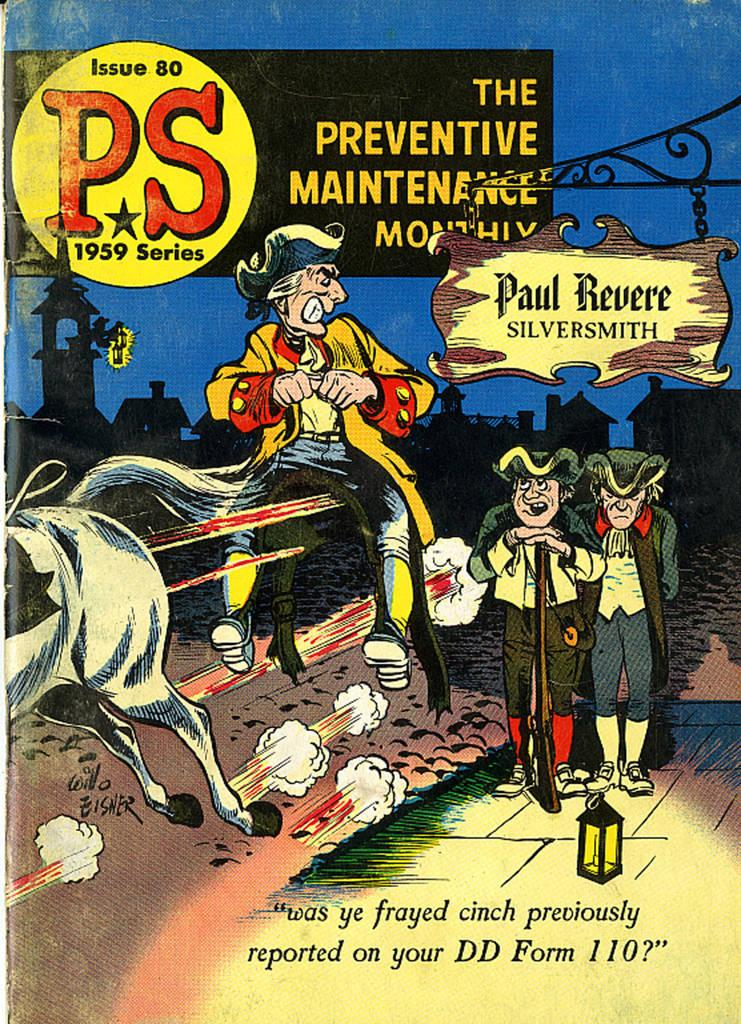Provide a one-sentence caption for the provided image. Issue 30 of The Preventive Maintenance Monthly magazine shoes men on the cover. 